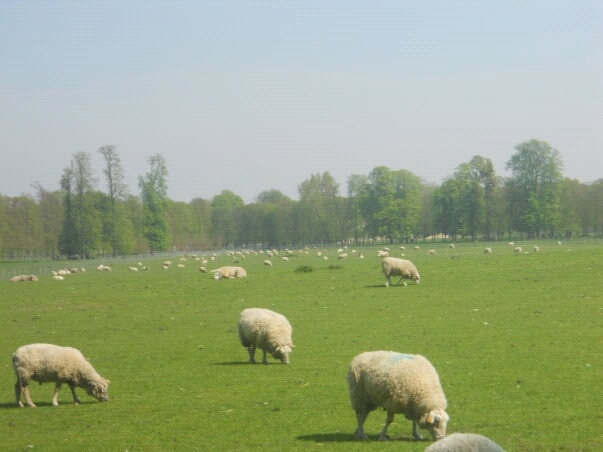Describe the objects in this image and their specific colors. I can see sheep in lightblue, tan, darkgreen, and olive tones, sheep in lightblue, tan, and darkgreen tones, sheep in lightblue, tan, darkgreen, and olive tones, sheep in lightblue, olive, tan, and darkgreen tones, and sheep in lightblue, darkgray, beige, gray, and tan tones in this image. 